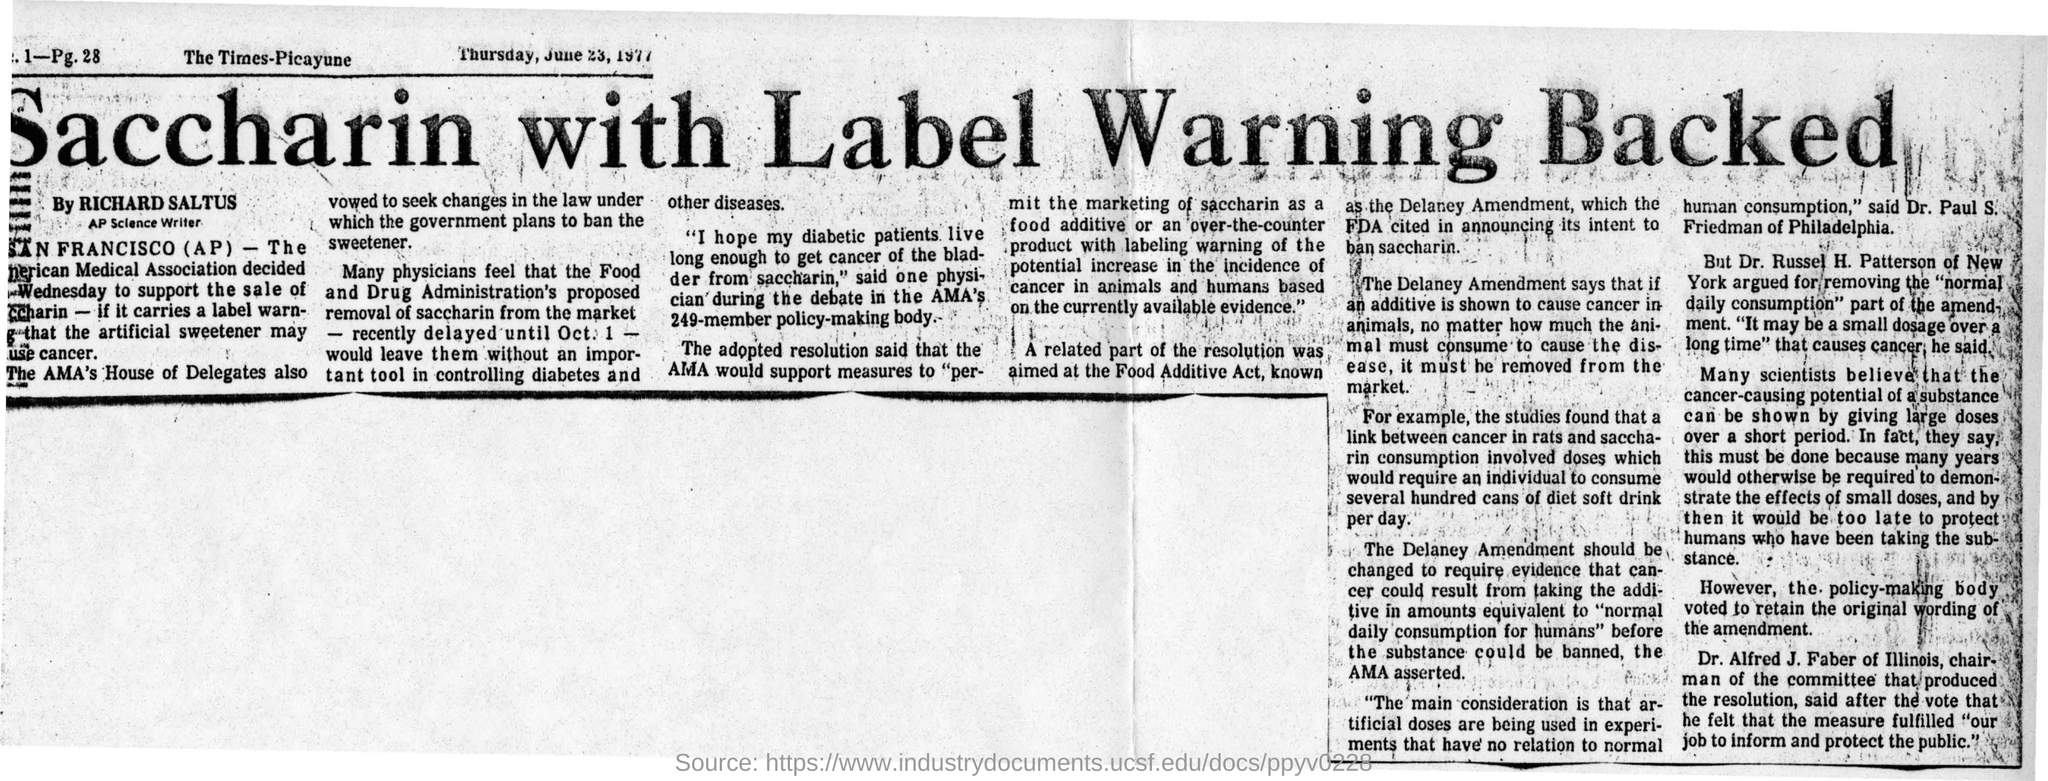Indicate a few pertinent items in this graphic. The AP Science Writer is Richard Saltus. The newspaper's name is The Times-Picayune. The date mentioned in the newspaper is Thursday, June 23, 1977. The use of saccharin with a label warning has been backed by news headlines. 